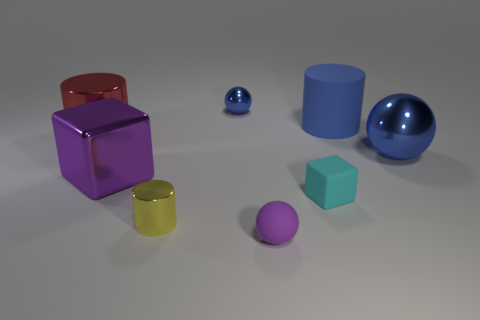What color is the big metal ball?
Ensure brevity in your answer.  Blue. Does the small shiny object in front of the large red cylinder have the same color as the big matte cylinder?
Provide a short and direct response. No. What color is the tiny matte thing that is the same shape as the big purple metallic object?
Make the answer very short. Cyan. What number of big objects are cyan balls or red cylinders?
Keep it short and to the point. 1. There is a blue shiny object on the left side of the small cyan matte cube; how big is it?
Your answer should be very brief. Small. Is there another sphere that has the same color as the rubber sphere?
Provide a succinct answer. No. Do the large metal ball and the tiny rubber cube have the same color?
Your answer should be compact. No. What is the shape of the large thing that is the same color as the big rubber cylinder?
Your answer should be compact. Sphere. How many small yellow shiny objects are behind the tiny object behind the big metallic cube?
Provide a short and direct response. 0. What number of big yellow objects are the same material as the tiny yellow cylinder?
Keep it short and to the point. 0. 